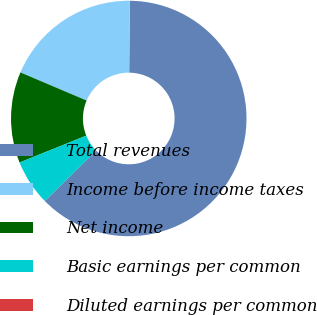Convert chart. <chart><loc_0><loc_0><loc_500><loc_500><pie_chart><fcel>Total revenues<fcel>Income before income taxes<fcel>Net income<fcel>Basic earnings per common<fcel>Diluted earnings per common<nl><fcel>62.5%<fcel>18.75%<fcel>12.5%<fcel>6.25%<fcel>0.0%<nl></chart> 